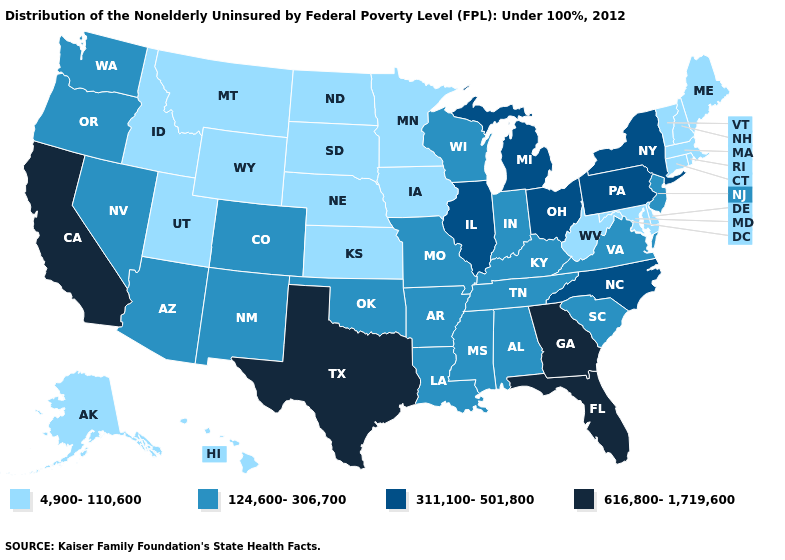Does Louisiana have a higher value than Minnesota?
Write a very short answer. Yes. Does the first symbol in the legend represent the smallest category?
Quick response, please. Yes. Does New Hampshire have a higher value than Arizona?
Answer briefly. No. What is the lowest value in states that border South Dakota?
Quick response, please. 4,900-110,600. Does Wyoming have the same value as Idaho?
Answer briefly. Yes. Name the states that have a value in the range 616,800-1,719,600?
Keep it brief. California, Florida, Georgia, Texas. Which states have the lowest value in the USA?
Give a very brief answer. Alaska, Connecticut, Delaware, Hawaii, Idaho, Iowa, Kansas, Maine, Maryland, Massachusetts, Minnesota, Montana, Nebraska, New Hampshire, North Dakota, Rhode Island, South Dakota, Utah, Vermont, West Virginia, Wyoming. What is the value of South Dakota?
Give a very brief answer. 4,900-110,600. Name the states that have a value in the range 616,800-1,719,600?
Quick response, please. California, Florida, Georgia, Texas. Does Kentucky have the same value as West Virginia?
Answer briefly. No. What is the highest value in the South ?
Keep it brief. 616,800-1,719,600. Among the states that border Oregon , which have the lowest value?
Write a very short answer. Idaho. What is the value of South Dakota?
Concise answer only. 4,900-110,600. Which states have the highest value in the USA?
Quick response, please. California, Florida, Georgia, Texas. Does Massachusetts have the lowest value in the USA?
Be succinct. Yes. 